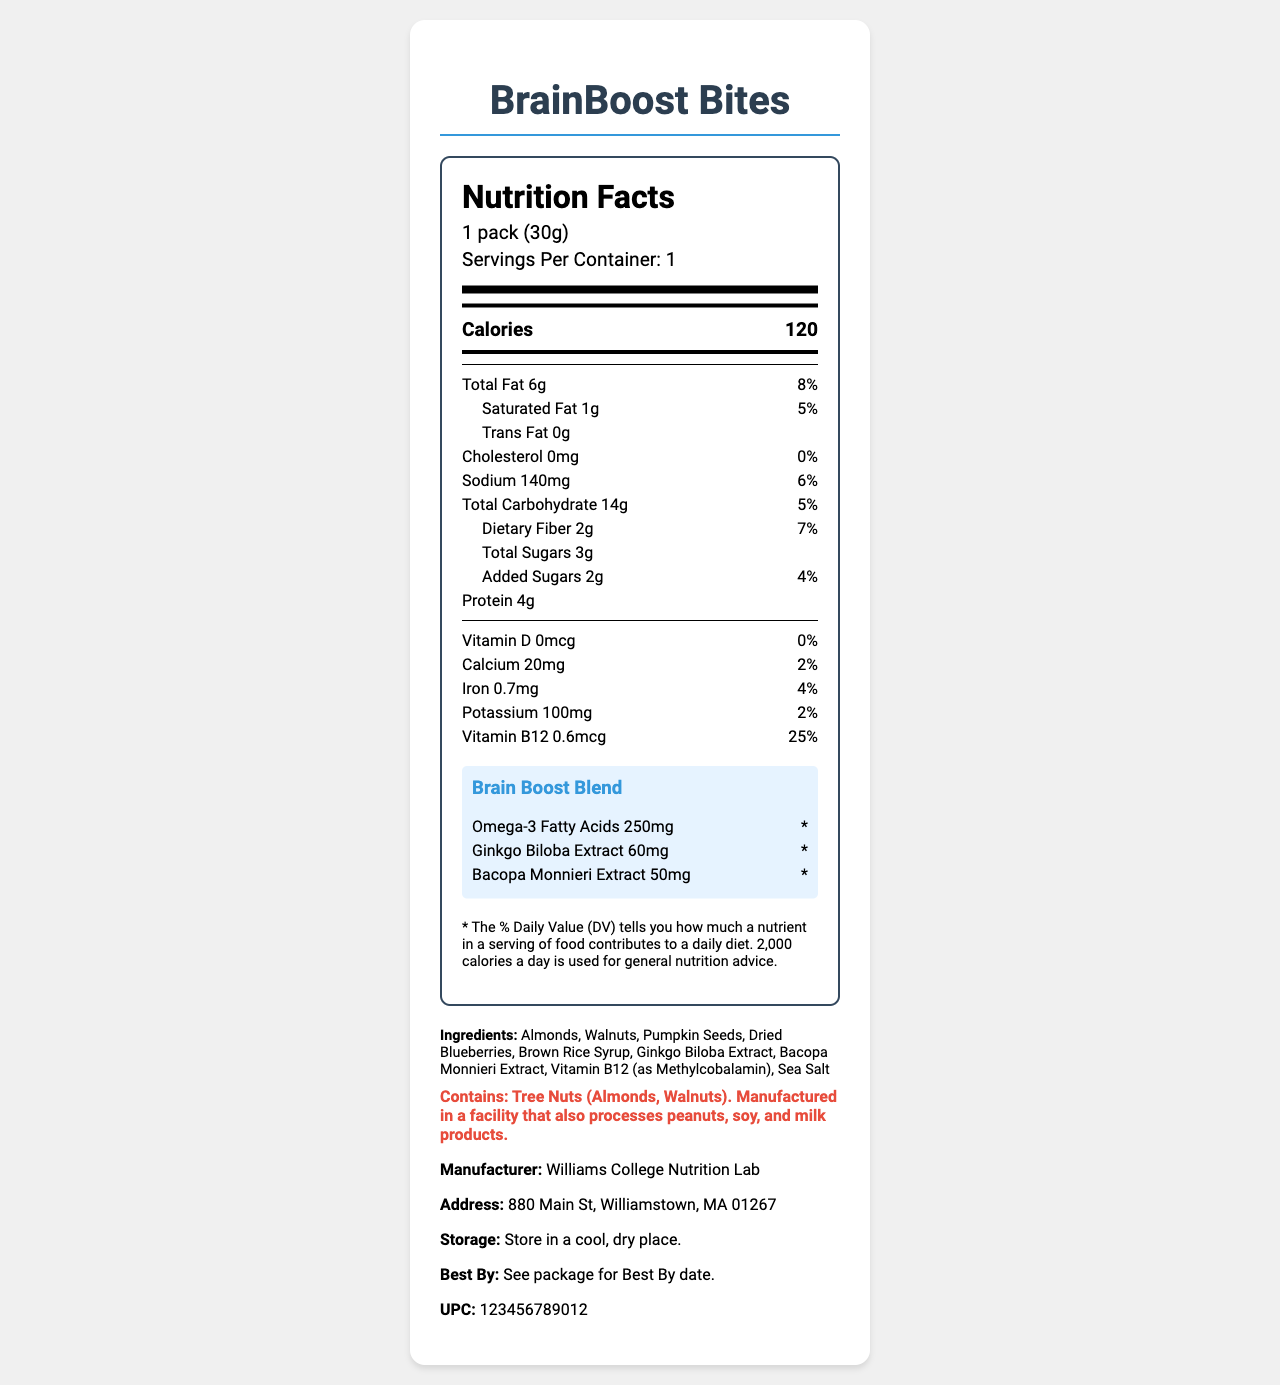what is the product name? The product name is clearly listed at the top of the document.
Answer: BrainBoost Bites How many grams of total fat does one pack of BrainBoost Bites contain? The Nutrition Facts section shows that the Total Fat content per pack is 6g.
Answer: 6g How many calories are in one serving of BrainBoost Bites? The document states that one serving (1 pack) of BrainBoost Bites contains 120 calories.
Answer: 120 What is the serving size for BrainBoost Bites? The serving size is listed as "1 pack (30g)" on the document.
Answer: 1 pack (30g) How many grams of dietary fiber are in BrainBoost Bites? The dietary fiber content is shown as 2g in the Nutrition Facts.
Answer: 2g What is the daily value percentage for Vitamin B12 in BrainBoost Bites? The document indicates that Vitamin B12 has a daily value percentage of 25%.
Answer: 25% Which nutrient has a daily value of 0% in BrainBoost Bites? A. Cholesterol B. Sodium C. Vitamin D The daily value percentage for Cholesterol is listed as 0%.
Answer: A What is the amount of sodium in one pack of BrainBoost Bites? A. 0mg B. 140mg C. 100mg D. 4g The document states that the sodium content is 140mg.
Answer: B Does BrainBoost Bites contain any trans fat? The document shows that the Trans Fat content is 0g.
Answer: No Can BrainBoost Bites be stored in a refrigerator? The document advises to "Store in a cool, dry place", but does not specify if refrigeration is suitable.
Answer: Not enough information Summarize the main components of the Nutrition Facts section for BrainBoost Bites. The summary captures the key nutrients and special ingredients, giving a comprehensive overview of the nutrition label.
Answer: BrainBoost Bites have a serving size of 1 pack (30g) with 120 calories. The main components include 6g of total fat, 14g of total carbohydrates, 4g of protein, and essential vitamins and minerals like iron, calcium, and Vitamin B12. The brain-boosting blend includes Omega-3 Fatty Acids, Ginkgo Biloba Extract, and Bacopa Monnieri Extract. Which ingredients in BrainBoost Bites are labeled as allergens? The allergen information section mentions that the product contains tree nuts specifically almonds and walnuts.
Answer: Tree Nuts (Almonds, Walnuts) What is the UPC code for BrainBoost Bites? The UPC code listed on the document is 123456789012.
Answer: 123456789012 What is the address of the manufacturer? The address provided for the manufacturer, Williams College Nutrition Lab, is 880 Main St, Williamstown, MA 01267.
Answer: 880 Main St, Williamstown, MA 01267 When does the product expire? The document advises to check the package for the Best By date.
Answer: See package for Best By date What is the amount of Omega-3 Fatty Acids in each serving of BrainBoost Bites? The document specifies that each serving contains 250mg of Omega-3 Fatty Acids.
Answer: 250mg 